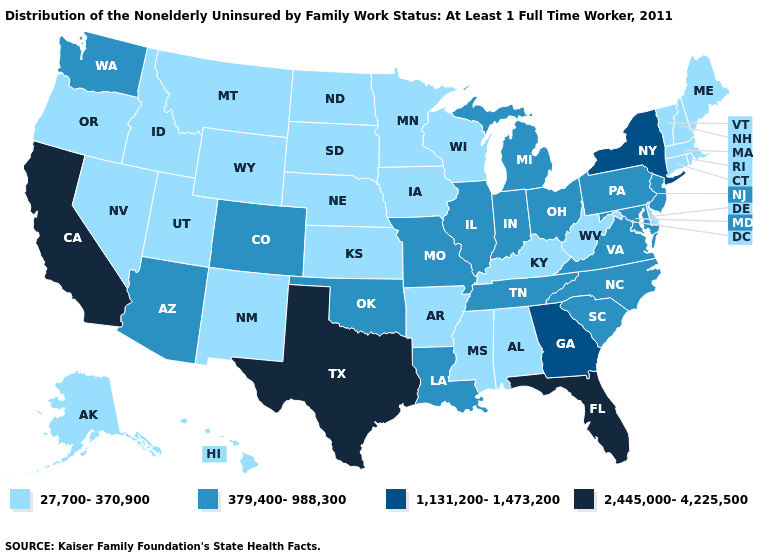Does Missouri have a lower value than Texas?
Keep it brief. Yes. What is the highest value in the USA?
Be succinct. 2,445,000-4,225,500. Does Michigan have the lowest value in the USA?
Be succinct. No. Which states have the lowest value in the MidWest?
Be succinct. Iowa, Kansas, Minnesota, Nebraska, North Dakota, South Dakota, Wisconsin. Does South Carolina have the same value as New Jersey?
Short answer required. Yes. Name the states that have a value in the range 2,445,000-4,225,500?
Short answer required. California, Florida, Texas. Which states have the highest value in the USA?
Short answer required. California, Florida, Texas. Does Indiana have the same value as Georgia?
Keep it brief. No. What is the value of New Jersey?
Answer briefly. 379,400-988,300. Name the states that have a value in the range 379,400-988,300?
Be succinct. Arizona, Colorado, Illinois, Indiana, Louisiana, Maryland, Michigan, Missouri, New Jersey, North Carolina, Ohio, Oklahoma, Pennsylvania, South Carolina, Tennessee, Virginia, Washington. Does the map have missing data?
Give a very brief answer. No. What is the lowest value in the South?
Be succinct. 27,700-370,900. What is the value of New York?
Be succinct. 1,131,200-1,473,200. What is the highest value in the MidWest ?
Write a very short answer. 379,400-988,300. Name the states that have a value in the range 1,131,200-1,473,200?
Be succinct. Georgia, New York. 